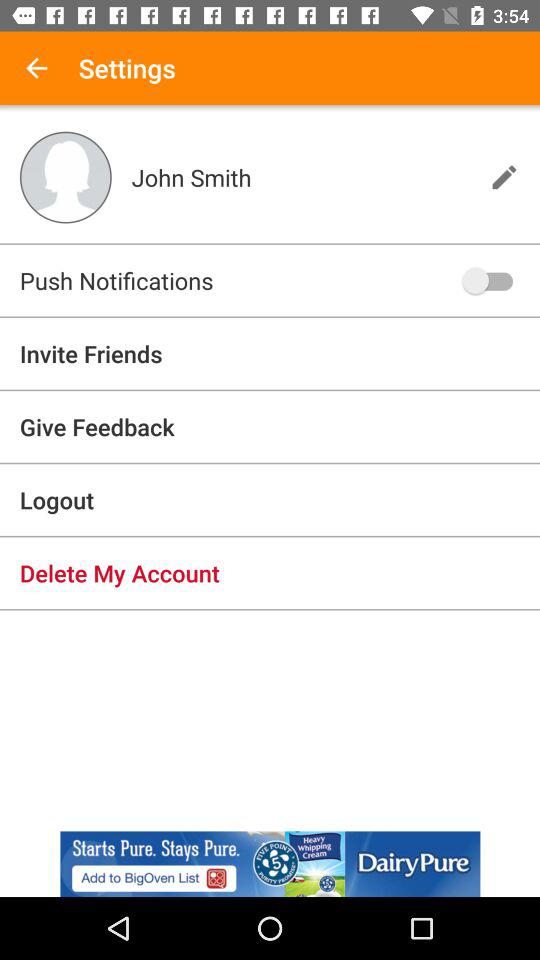What is the user's name? The user's name is John Smith. 